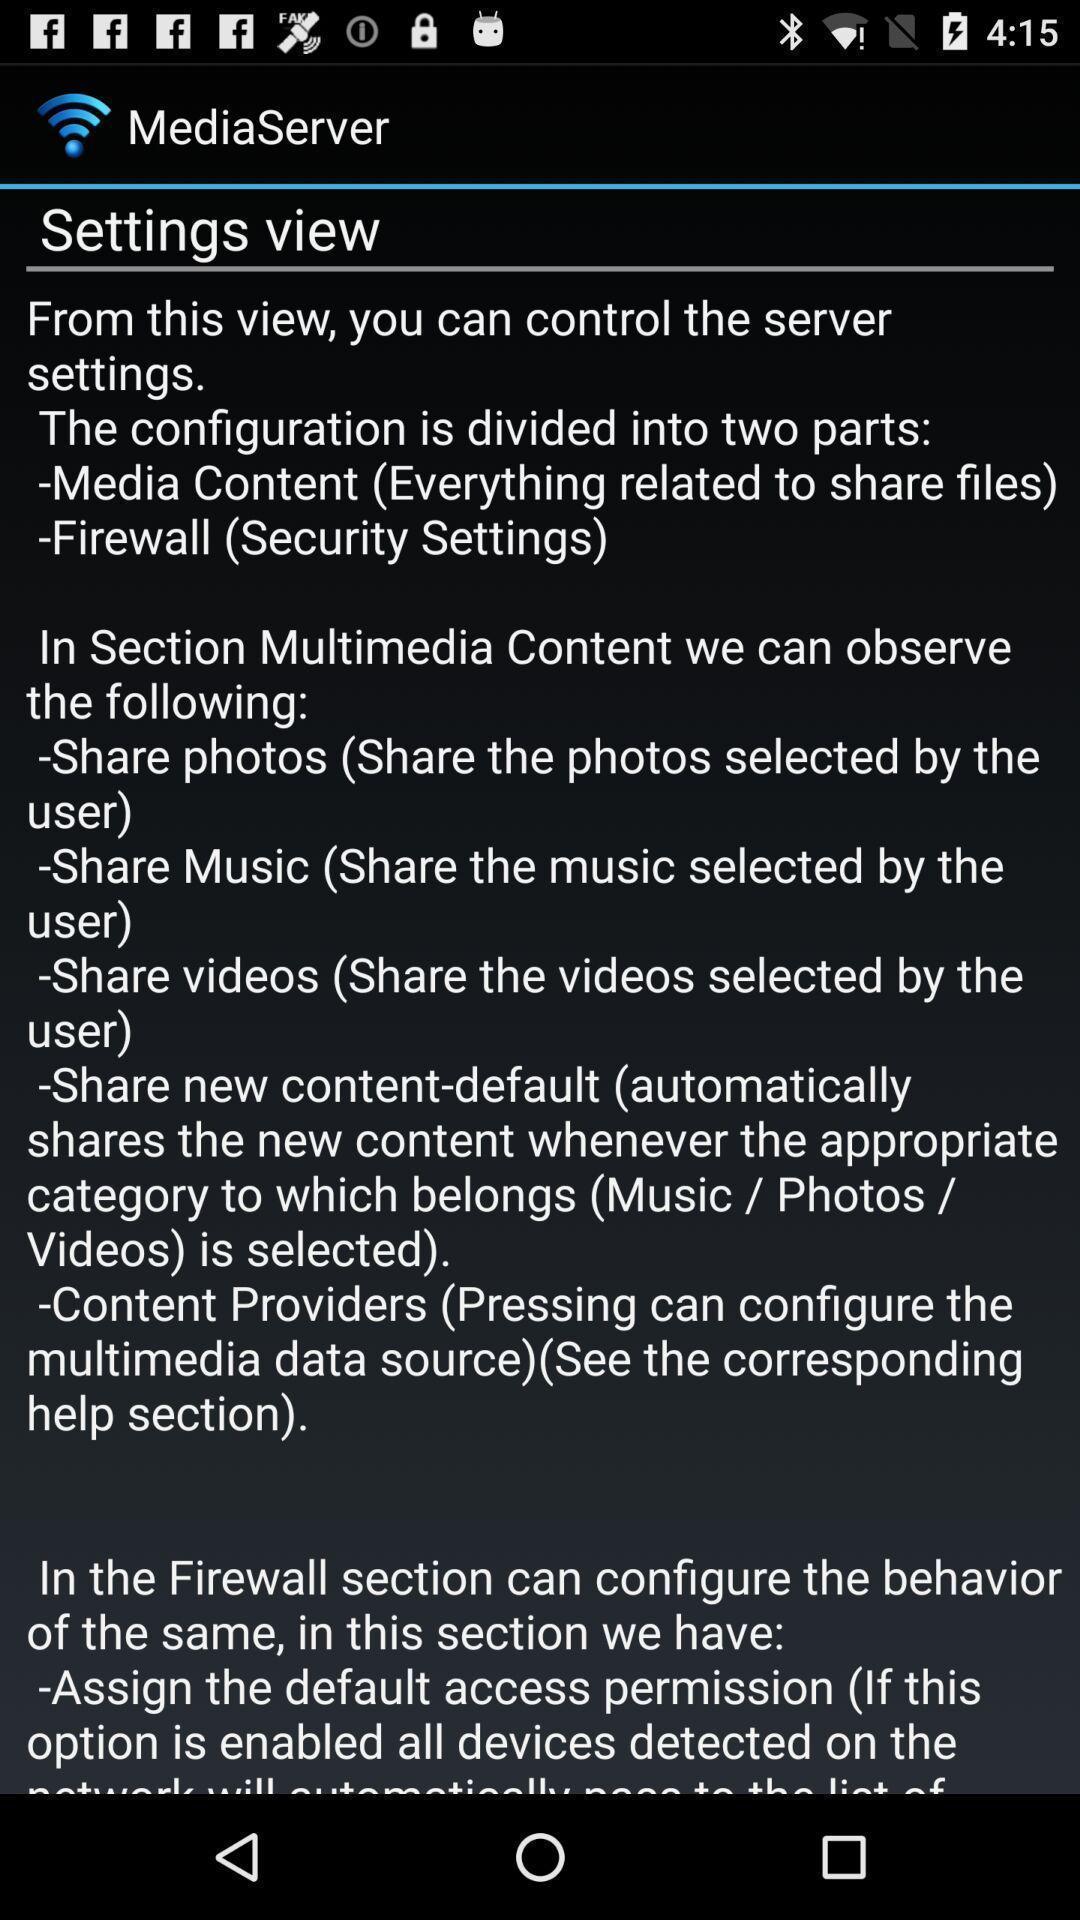Tell me about the visual elements in this screen capture. Settings page contains instructions to control server. 